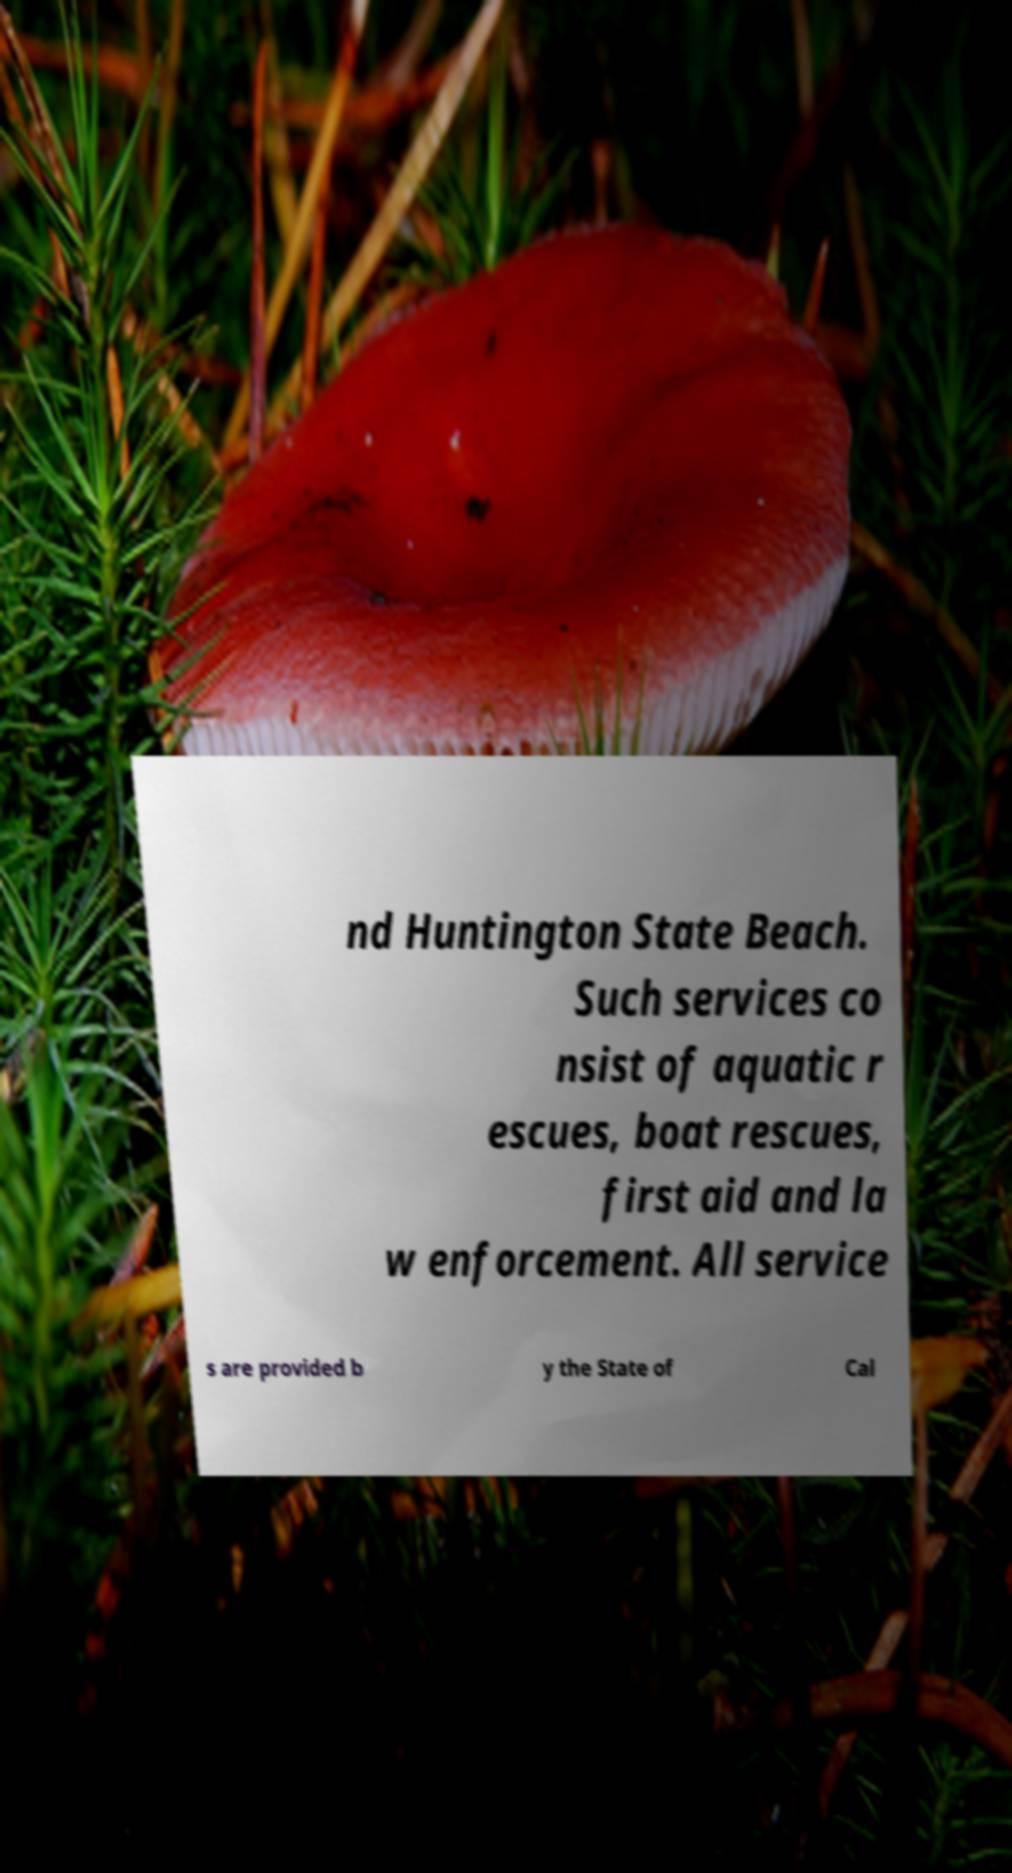I need the written content from this picture converted into text. Can you do that? nd Huntington State Beach. Such services co nsist of aquatic r escues, boat rescues, first aid and la w enforcement. All service s are provided b y the State of Cal 